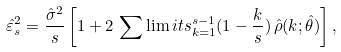<formula> <loc_0><loc_0><loc_500><loc_500>\hat { \varepsilon } ^ { 2 } _ { s } = \frac { \hat { \sigma } ^ { 2 } } { s } \left [ 1 + 2 \, \sum \lim i t s _ { k = 1 } ^ { s - 1 } ( 1 - \frac { k } { s } ) \, \hat { \rho } ( k ; \hat { \theta } ) \right ] ,</formula> 